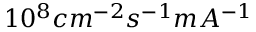Convert formula to latex. <formula><loc_0><loc_0><loc_500><loc_500>1 0 ^ { 8 } c m ^ { - 2 } s ^ { - 1 } m A ^ { - 1 }</formula> 